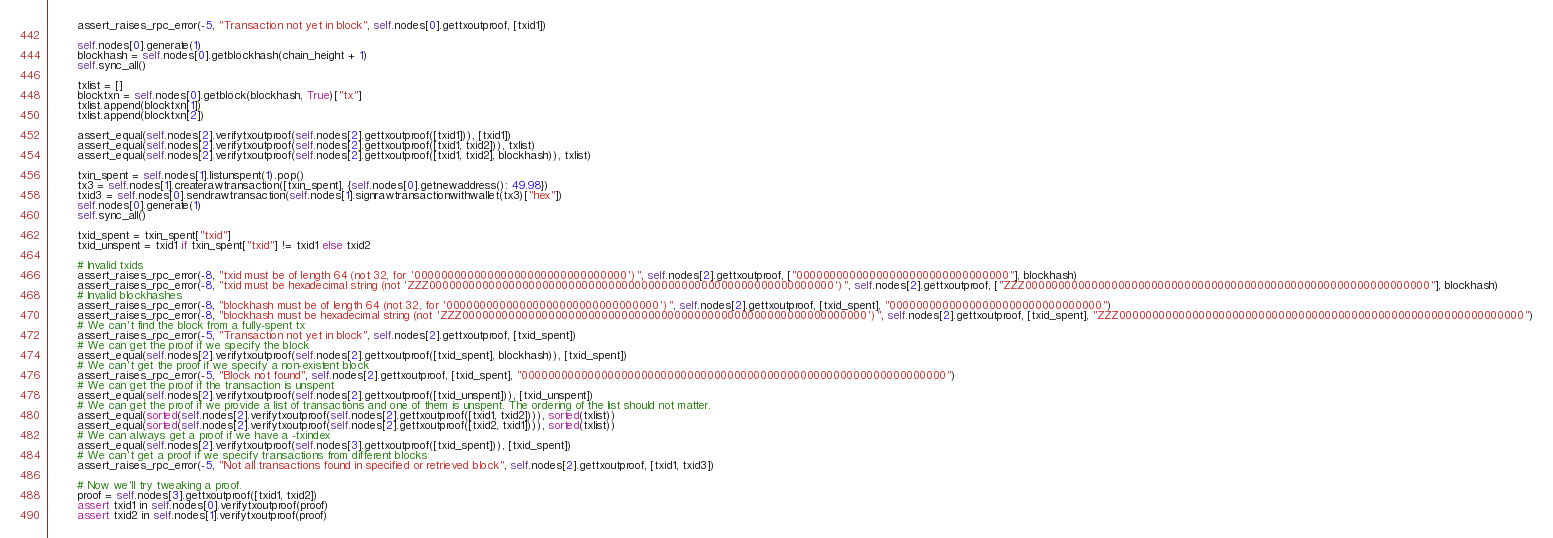<code> <loc_0><loc_0><loc_500><loc_500><_Python_>        assert_raises_rpc_error(-5, "Transaction not yet in block", self.nodes[0].gettxoutproof, [txid1])

        self.nodes[0].generate(1)
        blockhash = self.nodes[0].getblockhash(chain_height + 1)
        self.sync_all()

        txlist = []
        blocktxn = self.nodes[0].getblock(blockhash, True)["tx"]
        txlist.append(blocktxn[1])
        txlist.append(blocktxn[2])

        assert_equal(self.nodes[2].verifytxoutproof(self.nodes[2].gettxoutproof([txid1])), [txid1])
        assert_equal(self.nodes[2].verifytxoutproof(self.nodes[2].gettxoutproof([txid1, txid2])), txlist)
        assert_equal(self.nodes[2].verifytxoutproof(self.nodes[2].gettxoutproof([txid1, txid2], blockhash)), txlist)

        txin_spent = self.nodes[1].listunspent(1).pop()
        tx3 = self.nodes[1].createrawtransaction([txin_spent], {self.nodes[0].getnewaddress(): 49.98})
        txid3 = self.nodes[0].sendrawtransaction(self.nodes[1].signrawtransactionwithwallet(tx3)["hex"])
        self.nodes[0].generate(1)
        self.sync_all()

        txid_spent = txin_spent["txid"]
        txid_unspent = txid1 if txin_spent["txid"] != txid1 else txid2

        # Invalid txids
        assert_raises_rpc_error(-8, "txid must be of length 64 (not 32, for '00000000000000000000000000000000')", self.nodes[2].gettxoutproof, ["00000000000000000000000000000000"], blockhash)
        assert_raises_rpc_error(-8, "txid must be hexadecimal string (not 'ZZZ0000000000000000000000000000000000000000000000000000000000000')", self.nodes[2].gettxoutproof, ["ZZZ0000000000000000000000000000000000000000000000000000000000000"], blockhash)
        # Invalid blockhashes
        assert_raises_rpc_error(-8, "blockhash must be of length 64 (not 32, for '00000000000000000000000000000000')", self.nodes[2].gettxoutproof, [txid_spent], "00000000000000000000000000000000")
        assert_raises_rpc_error(-8, "blockhash must be hexadecimal string (not 'ZZZ0000000000000000000000000000000000000000000000000000000000000')", self.nodes[2].gettxoutproof, [txid_spent], "ZZZ0000000000000000000000000000000000000000000000000000000000000")
        # We can't find the block from a fully-spent tx
        assert_raises_rpc_error(-5, "Transaction not yet in block", self.nodes[2].gettxoutproof, [txid_spent])
        # We can get the proof if we specify the block
        assert_equal(self.nodes[2].verifytxoutproof(self.nodes[2].gettxoutproof([txid_spent], blockhash)), [txid_spent])
        # We can't get the proof if we specify a non-existent block
        assert_raises_rpc_error(-5, "Block not found", self.nodes[2].gettxoutproof, [txid_spent], "0000000000000000000000000000000000000000000000000000000000000000")
        # We can get the proof if the transaction is unspent
        assert_equal(self.nodes[2].verifytxoutproof(self.nodes[2].gettxoutproof([txid_unspent])), [txid_unspent])
        # We can get the proof if we provide a list of transactions and one of them is unspent. The ordering of the list should not matter.
        assert_equal(sorted(self.nodes[2].verifytxoutproof(self.nodes[2].gettxoutproof([txid1, txid2]))), sorted(txlist))
        assert_equal(sorted(self.nodes[2].verifytxoutproof(self.nodes[2].gettxoutproof([txid2, txid1]))), sorted(txlist))
        # We can always get a proof if we have a -txindex
        assert_equal(self.nodes[2].verifytxoutproof(self.nodes[3].gettxoutproof([txid_spent])), [txid_spent])
        # We can't get a proof if we specify transactions from different blocks
        assert_raises_rpc_error(-5, "Not all transactions found in specified or retrieved block", self.nodes[2].gettxoutproof, [txid1, txid3])

        # Now we'll try tweaking a proof.
        proof = self.nodes[3].gettxoutproof([txid1, txid2])
        assert txid1 in self.nodes[0].verifytxoutproof(proof)
        assert txid2 in self.nodes[1].verifytxoutproof(proof)
</code> 